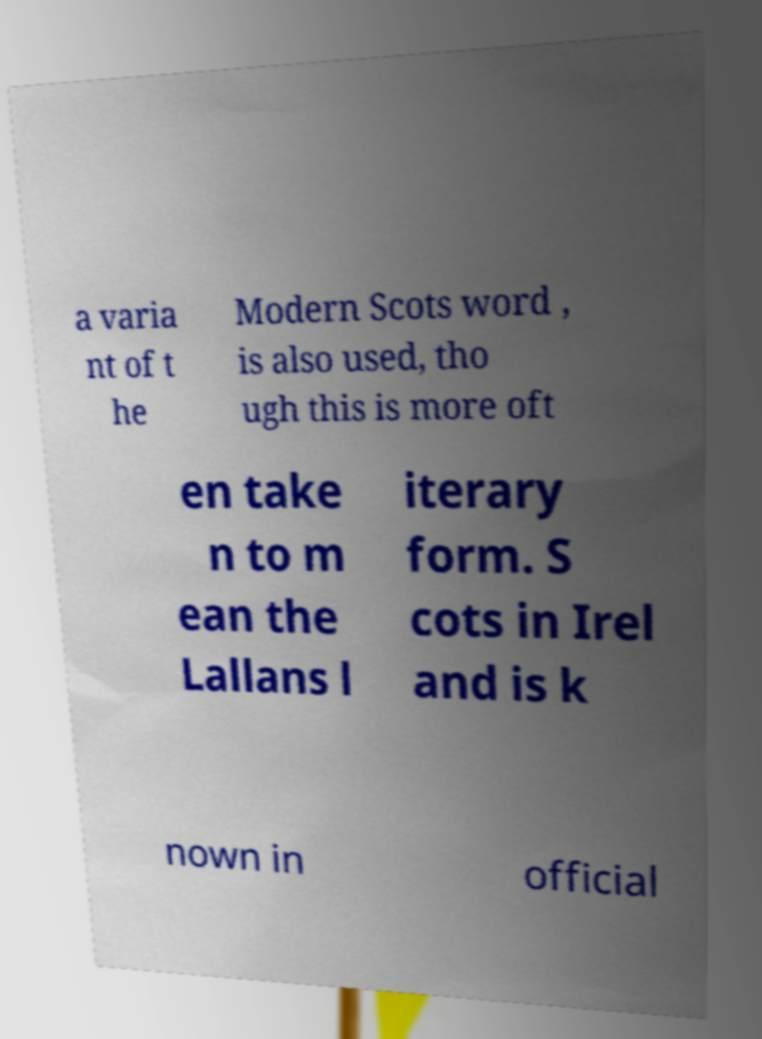I need the written content from this picture converted into text. Can you do that? a varia nt of t he Modern Scots word , is also used, tho ugh this is more oft en take n to m ean the Lallans l iterary form. S cots in Irel and is k nown in official 